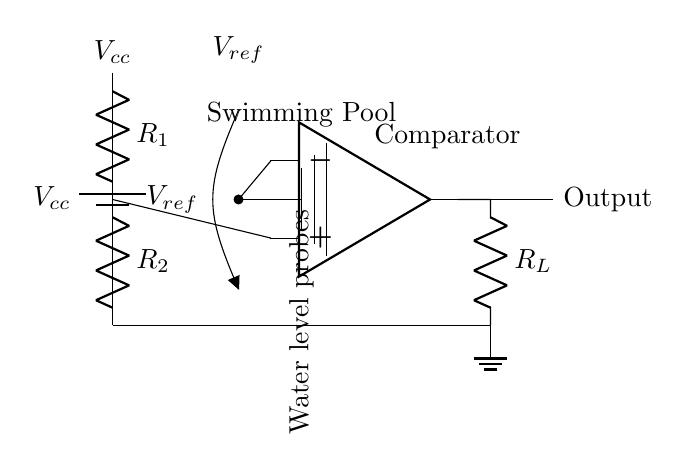What is the reference voltage in the circuit? The reference voltage is labeled as V ref in the diagram. This is the voltage against which the water level is compared to determine if the pool should be filled or drained.
Answer: V ref What is the function of the comparator in this circuit? The comparator compares the voltage from the water level probes with the reference voltage. It determines whether the water level is above or below a certain threshold, thus controlling the output signal accordingly.
Answer: Compare water levels What type of circuit is this? The circuit is a water level sensing circuit, designed specifically for monitoring and maintaining the water level in swimming pools.
Answer: Water level sensing circuit What are the resistors used for in this circuit? The resistors, labeled as R 1 and R 2, form a voltage divider that reduces the voltage coming from V cc to a suitable level for the comparator. The voltage at the midpoint of these resistors is used in the comparison.
Answer: Voltage divider How many voltage sources are present in the circuit? There are two voltage sources: V cc and V ref. V cc powers the circuit, while V ref serves as a reference point for comparison.
Answer: Two What does the output of the comparator control in this circuit? The output of the comparator controls the state determined by the water level, indicating whether the pump should be activated or deactivated to maintain the desired water level in the swimming pool.
Answer: Pump control 